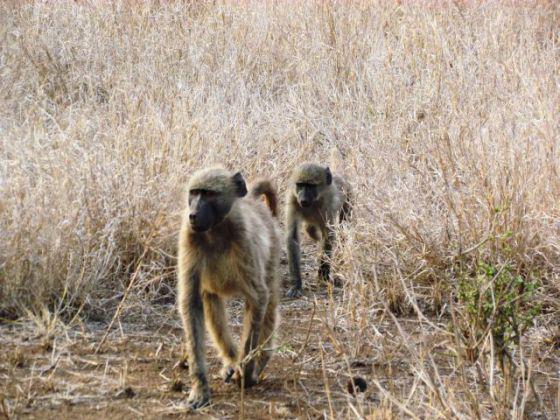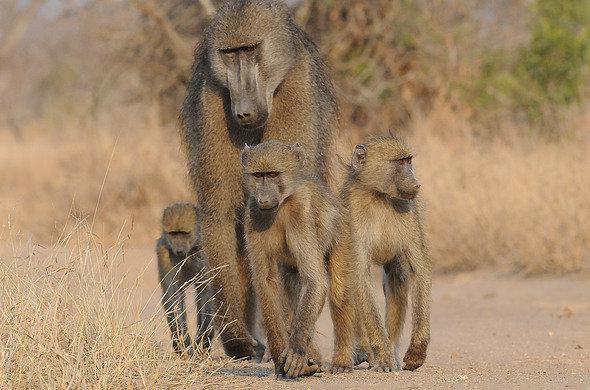The first image is the image on the left, the second image is the image on the right. Examine the images to the left and right. Is the description "The left image contains no more than two monkeys." accurate? Answer yes or no. Yes. The first image is the image on the left, the second image is the image on the right. Analyze the images presented: Is the assertion "The combined images contain six baboons." valid? Answer yes or no. Yes. 